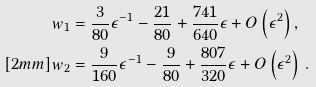Convert formula to latex. <formula><loc_0><loc_0><loc_500><loc_500>w _ { 1 } & = \frac { 3 } { 8 0 } \epsilon ^ { - 1 } - \frac { 2 1 } { 8 0 } + \frac { 7 4 1 } { 6 4 0 } \epsilon + O \left ( \epsilon ^ { 2 } \right ) , \\ [ 2 m m ] w _ { 2 } & = \frac { 9 } { 1 6 0 } \epsilon ^ { - 1 } - \frac { 9 } { 8 0 } + \frac { 8 0 7 } { 3 2 0 } \epsilon + O \left ( \epsilon ^ { 2 } \right ) \, .</formula> 